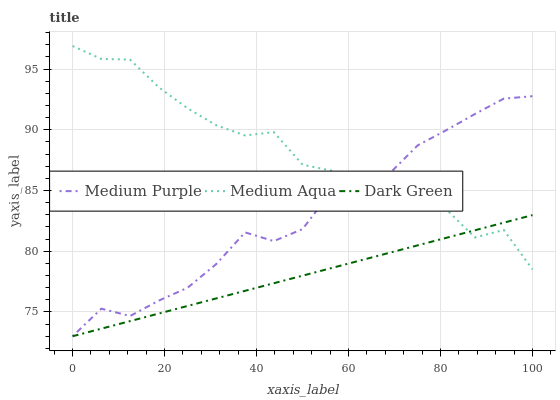Does Dark Green have the minimum area under the curve?
Answer yes or no. Yes. Does Medium Aqua have the maximum area under the curve?
Answer yes or no. Yes. Does Medium Aqua have the minimum area under the curve?
Answer yes or no. No. Does Dark Green have the maximum area under the curve?
Answer yes or no. No. Is Dark Green the smoothest?
Answer yes or no. Yes. Is Medium Aqua the roughest?
Answer yes or no. Yes. Is Medium Aqua the smoothest?
Answer yes or no. No. Is Dark Green the roughest?
Answer yes or no. No. Does Medium Aqua have the lowest value?
Answer yes or no. No. Does Medium Aqua have the highest value?
Answer yes or no. Yes. Does Dark Green have the highest value?
Answer yes or no. No. Does Medium Aqua intersect Medium Purple?
Answer yes or no. Yes. Is Medium Aqua less than Medium Purple?
Answer yes or no. No. Is Medium Aqua greater than Medium Purple?
Answer yes or no. No. 